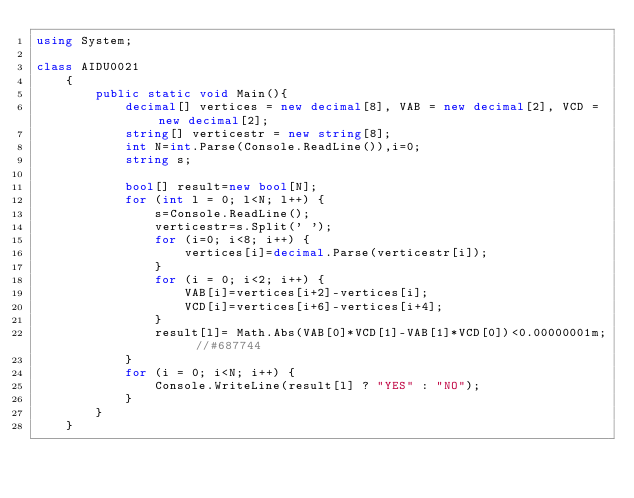<code> <loc_0><loc_0><loc_500><loc_500><_C#_>using System;

class AIDU0021
    {
        public static void Main(){
            decimal[] vertices = new decimal[8], VAB = new decimal[2], VCD = new decimal[2];
            string[] verticestr = new string[8];
            int N=int.Parse(Console.ReadLine()),i=0;
            string s;
            
            bool[] result=new bool[N];
            for (int l = 0; l<N; l++) {
                s=Console.ReadLine();
                verticestr=s.Split(' ');
                for (i=0; i<8; i++) {
                    vertices[i]=decimal.Parse(verticestr[i]); 
                }
                for (i = 0; i<2; i++) {
                    VAB[i]=vertices[i+2]-vertices[i];
                    VCD[i]=vertices[i+6]-vertices[i+4];
                }
                result[l]= Math.Abs(VAB[0]*VCD[1]-VAB[1]*VCD[0])<0.00000001m; //#687744
            }
            for (i = 0; i<N; i++) {
                Console.WriteLine(result[l] ? "YES" : "NO");
            }
        }
    }</code> 